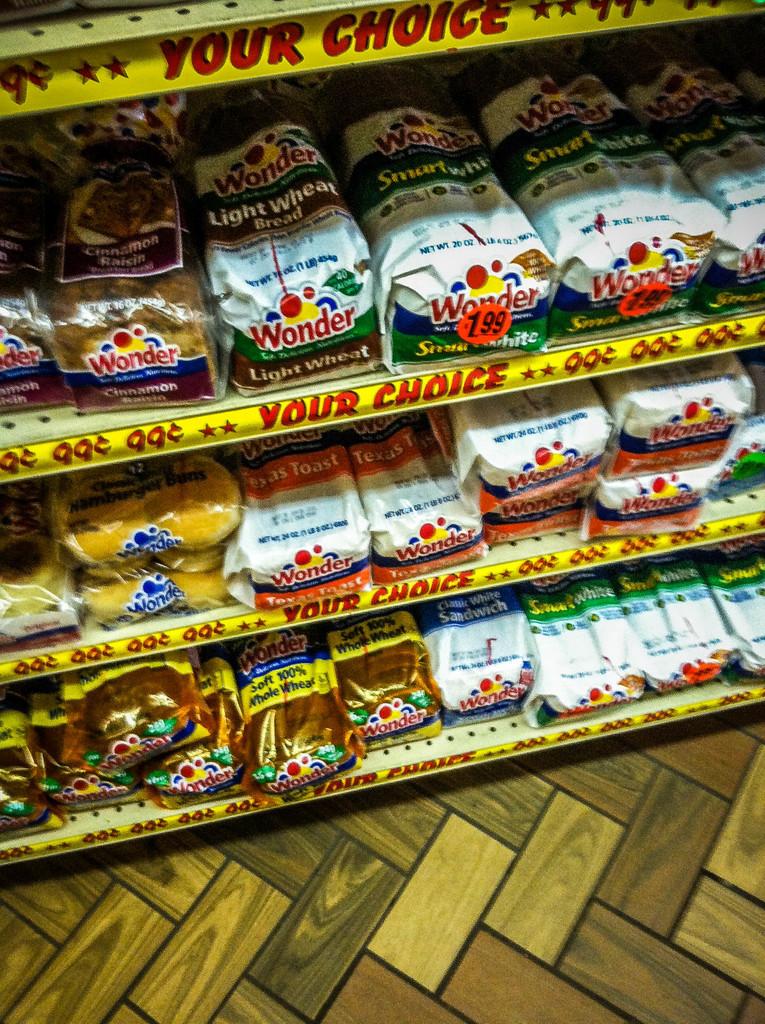What brand of bread has the tag on it?
Offer a terse response. Wonder. How much does the bread cost?
Ensure brevity in your answer.  1.99. 